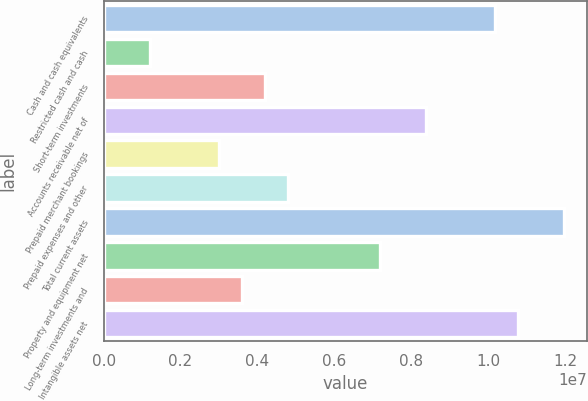Convert chart. <chart><loc_0><loc_0><loc_500><loc_500><bar_chart><fcel>Cash and cash equivalents<fcel>Restricted cash and cash<fcel>Short-term investments<fcel>Accounts receivable net of<fcel>Prepaid merchant bookings<fcel>Prepaid expenses and other<fcel>Total current assets<fcel>Property and equipment net<fcel>Long-term investments and<fcel>Intangible assets net<nl><fcel>1.01651e+07<fcel>1.19592e+06<fcel>4.18565e+06<fcel>8.37127e+06<fcel>2.98976e+06<fcel>4.78359e+06<fcel>1.19589e+07<fcel>7.17538e+06<fcel>3.5877e+06<fcel>1.07631e+07<nl></chart> 